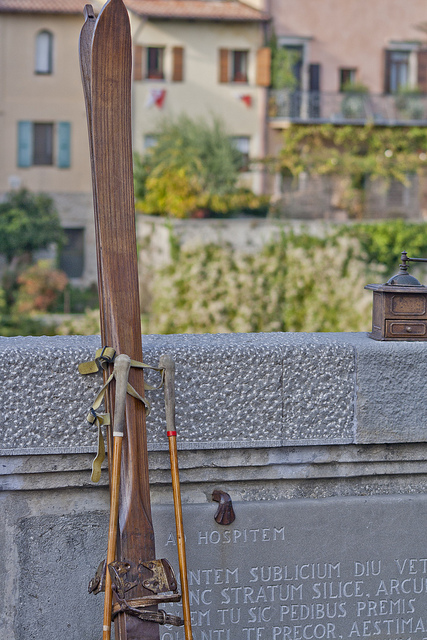Read all the text in this image. PREMIS HOSPITEM SUBLICIUM STRATUM SILICE DIU TEPPECOR AESTIMA PEDIBUS SIC TU ARCU VET NTEM A 